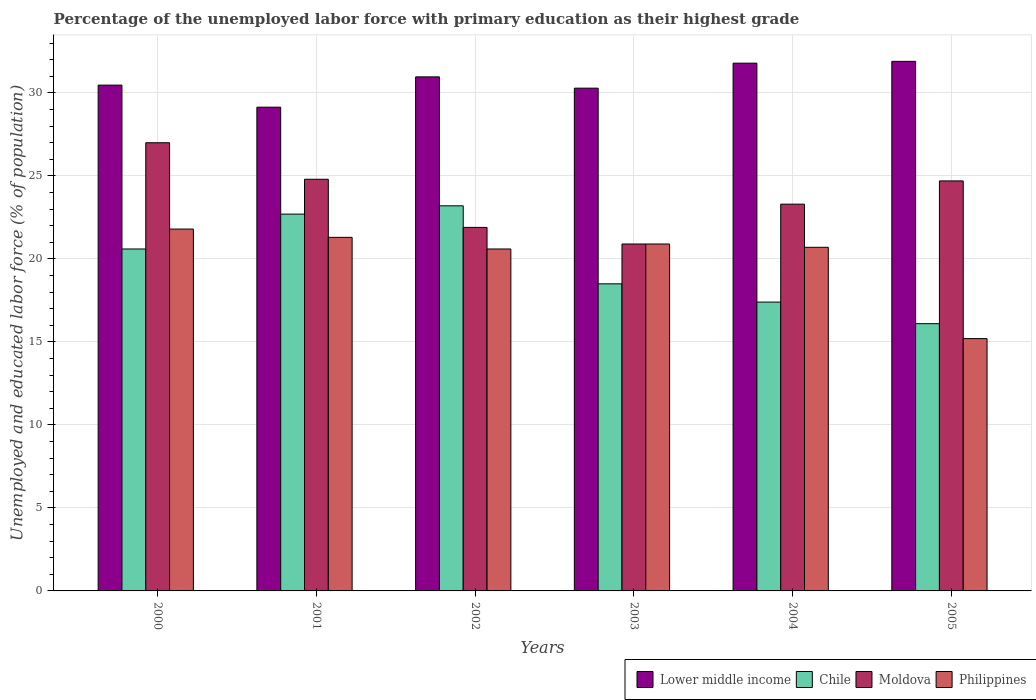How many different coloured bars are there?
Give a very brief answer. 4. How many groups of bars are there?
Your answer should be very brief. 6. Are the number of bars per tick equal to the number of legend labels?
Your answer should be compact. Yes. Are the number of bars on each tick of the X-axis equal?
Provide a short and direct response. Yes. How many bars are there on the 5th tick from the left?
Keep it short and to the point. 4. In how many cases, is the number of bars for a given year not equal to the number of legend labels?
Keep it short and to the point. 0. What is the percentage of the unemployed labor force with primary education in Philippines in 2005?
Provide a short and direct response. 15.2. Across all years, what is the maximum percentage of the unemployed labor force with primary education in Philippines?
Your answer should be very brief. 21.8. Across all years, what is the minimum percentage of the unemployed labor force with primary education in Chile?
Offer a terse response. 16.1. In which year was the percentage of the unemployed labor force with primary education in Philippines maximum?
Your answer should be compact. 2000. What is the total percentage of the unemployed labor force with primary education in Moldova in the graph?
Offer a very short reply. 142.6. What is the difference between the percentage of the unemployed labor force with primary education in Moldova in 2000 and that in 2004?
Ensure brevity in your answer.  3.7. What is the difference between the percentage of the unemployed labor force with primary education in Moldova in 2003 and the percentage of the unemployed labor force with primary education in Lower middle income in 2001?
Your answer should be very brief. -8.24. What is the average percentage of the unemployed labor force with primary education in Philippines per year?
Offer a very short reply. 20.08. In the year 2002, what is the difference between the percentage of the unemployed labor force with primary education in Chile and percentage of the unemployed labor force with primary education in Lower middle income?
Provide a succinct answer. -7.77. What is the ratio of the percentage of the unemployed labor force with primary education in Lower middle income in 2000 to that in 2004?
Ensure brevity in your answer.  0.96. Is the percentage of the unemployed labor force with primary education in Lower middle income in 2003 less than that in 2005?
Offer a terse response. Yes. Is the difference between the percentage of the unemployed labor force with primary education in Chile in 2000 and 2001 greater than the difference between the percentage of the unemployed labor force with primary education in Lower middle income in 2000 and 2001?
Your response must be concise. No. What is the difference between the highest and the second highest percentage of the unemployed labor force with primary education in Philippines?
Offer a terse response. 0.5. What is the difference between the highest and the lowest percentage of the unemployed labor force with primary education in Moldova?
Your answer should be compact. 6.1. In how many years, is the percentage of the unemployed labor force with primary education in Philippines greater than the average percentage of the unemployed labor force with primary education in Philippines taken over all years?
Make the answer very short. 5. What does the 4th bar from the left in 2000 represents?
Your answer should be very brief. Philippines. What does the 2nd bar from the right in 2005 represents?
Provide a short and direct response. Moldova. What is the difference between two consecutive major ticks on the Y-axis?
Offer a very short reply. 5. Are the values on the major ticks of Y-axis written in scientific E-notation?
Make the answer very short. No. Does the graph contain grids?
Your answer should be compact. Yes. What is the title of the graph?
Keep it short and to the point. Percentage of the unemployed labor force with primary education as their highest grade. Does "Suriname" appear as one of the legend labels in the graph?
Your answer should be very brief. No. What is the label or title of the X-axis?
Your answer should be compact. Years. What is the label or title of the Y-axis?
Offer a very short reply. Unemployed and educated labor force (% of population). What is the Unemployed and educated labor force (% of population) in Lower middle income in 2000?
Your answer should be compact. 30.47. What is the Unemployed and educated labor force (% of population) of Chile in 2000?
Your answer should be very brief. 20.6. What is the Unemployed and educated labor force (% of population) of Moldova in 2000?
Your answer should be compact. 27. What is the Unemployed and educated labor force (% of population) of Philippines in 2000?
Offer a very short reply. 21.8. What is the Unemployed and educated labor force (% of population) in Lower middle income in 2001?
Ensure brevity in your answer.  29.14. What is the Unemployed and educated labor force (% of population) in Chile in 2001?
Ensure brevity in your answer.  22.7. What is the Unemployed and educated labor force (% of population) in Moldova in 2001?
Provide a succinct answer. 24.8. What is the Unemployed and educated labor force (% of population) of Philippines in 2001?
Offer a terse response. 21.3. What is the Unemployed and educated labor force (% of population) of Lower middle income in 2002?
Make the answer very short. 30.97. What is the Unemployed and educated labor force (% of population) in Chile in 2002?
Your answer should be very brief. 23.2. What is the Unemployed and educated labor force (% of population) in Moldova in 2002?
Your answer should be compact. 21.9. What is the Unemployed and educated labor force (% of population) of Philippines in 2002?
Keep it short and to the point. 20.6. What is the Unemployed and educated labor force (% of population) of Lower middle income in 2003?
Your answer should be very brief. 30.29. What is the Unemployed and educated labor force (% of population) in Moldova in 2003?
Provide a short and direct response. 20.9. What is the Unemployed and educated labor force (% of population) of Philippines in 2003?
Your answer should be very brief. 20.9. What is the Unemployed and educated labor force (% of population) of Lower middle income in 2004?
Your response must be concise. 31.79. What is the Unemployed and educated labor force (% of population) of Chile in 2004?
Offer a terse response. 17.4. What is the Unemployed and educated labor force (% of population) of Moldova in 2004?
Your answer should be compact. 23.3. What is the Unemployed and educated labor force (% of population) in Philippines in 2004?
Offer a terse response. 20.7. What is the Unemployed and educated labor force (% of population) of Lower middle income in 2005?
Keep it short and to the point. 31.9. What is the Unemployed and educated labor force (% of population) of Chile in 2005?
Provide a short and direct response. 16.1. What is the Unemployed and educated labor force (% of population) in Moldova in 2005?
Ensure brevity in your answer.  24.7. What is the Unemployed and educated labor force (% of population) in Philippines in 2005?
Make the answer very short. 15.2. Across all years, what is the maximum Unemployed and educated labor force (% of population) in Lower middle income?
Your answer should be very brief. 31.9. Across all years, what is the maximum Unemployed and educated labor force (% of population) of Chile?
Keep it short and to the point. 23.2. Across all years, what is the maximum Unemployed and educated labor force (% of population) of Moldova?
Offer a very short reply. 27. Across all years, what is the maximum Unemployed and educated labor force (% of population) of Philippines?
Give a very brief answer. 21.8. Across all years, what is the minimum Unemployed and educated labor force (% of population) of Lower middle income?
Offer a very short reply. 29.14. Across all years, what is the minimum Unemployed and educated labor force (% of population) of Chile?
Provide a succinct answer. 16.1. Across all years, what is the minimum Unemployed and educated labor force (% of population) in Moldova?
Your answer should be very brief. 20.9. Across all years, what is the minimum Unemployed and educated labor force (% of population) of Philippines?
Provide a short and direct response. 15.2. What is the total Unemployed and educated labor force (% of population) in Lower middle income in the graph?
Keep it short and to the point. 184.57. What is the total Unemployed and educated labor force (% of population) in Chile in the graph?
Your answer should be very brief. 118.5. What is the total Unemployed and educated labor force (% of population) in Moldova in the graph?
Provide a succinct answer. 142.6. What is the total Unemployed and educated labor force (% of population) in Philippines in the graph?
Your answer should be very brief. 120.5. What is the difference between the Unemployed and educated labor force (% of population) of Lower middle income in 2000 and that in 2001?
Provide a succinct answer. 1.33. What is the difference between the Unemployed and educated labor force (% of population) of Philippines in 2000 and that in 2001?
Provide a succinct answer. 0.5. What is the difference between the Unemployed and educated labor force (% of population) of Lower middle income in 2000 and that in 2002?
Your answer should be compact. -0.5. What is the difference between the Unemployed and educated labor force (% of population) in Chile in 2000 and that in 2002?
Offer a terse response. -2.6. What is the difference between the Unemployed and educated labor force (% of population) in Moldova in 2000 and that in 2002?
Offer a very short reply. 5.1. What is the difference between the Unemployed and educated labor force (% of population) of Philippines in 2000 and that in 2002?
Provide a succinct answer. 1.2. What is the difference between the Unemployed and educated labor force (% of population) of Lower middle income in 2000 and that in 2003?
Your response must be concise. 0.18. What is the difference between the Unemployed and educated labor force (% of population) in Chile in 2000 and that in 2003?
Give a very brief answer. 2.1. What is the difference between the Unemployed and educated labor force (% of population) in Moldova in 2000 and that in 2003?
Ensure brevity in your answer.  6.1. What is the difference between the Unemployed and educated labor force (% of population) in Lower middle income in 2000 and that in 2004?
Offer a terse response. -1.32. What is the difference between the Unemployed and educated labor force (% of population) in Chile in 2000 and that in 2004?
Your answer should be very brief. 3.2. What is the difference between the Unemployed and educated labor force (% of population) of Moldova in 2000 and that in 2004?
Give a very brief answer. 3.7. What is the difference between the Unemployed and educated labor force (% of population) of Lower middle income in 2000 and that in 2005?
Keep it short and to the point. -1.43. What is the difference between the Unemployed and educated labor force (% of population) of Moldova in 2000 and that in 2005?
Offer a terse response. 2.3. What is the difference between the Unemployed and educated labor force (% of population) in Philippines in 2000 and that in 2005?
Your answer should be very brief. 6.6. What is the difference between the Unemployed and educated labor force (% of population) of Lower middle income in 2001 and that in 2002?
Your answer should be very brief. -1.83. What is the difference between the Unemployed and educated labor force (% of population) of Moldova in 2001 and that in 2002?
Give a very brief answer. 2.9. What is the difference between the Unemployed and educated labor force (% of population) in Lower middle income in 2001 and that in 2003?
Your response must be concise. -1.15. What is the difference between the Unemployed and educated labor force (% of population) in Moldova in 2001 and that in 2003?
Make the answer very short. 3.9. What is the difference between the Unemployed and educated labor force (% of population) of Lower middle income in 2001 and that in 2004?
Your answer should be compact. -2.65. What is the difference between the Unemployed and educated labor force (% of population) in Moldova in 2001 and that in 2004?
Offer a very short reply. 1.5. What is the difference between the Unemployed and educated labor force (% of population) of Lower middle income in 2001 and that in 2005?
Your answer should be very brief. -2.76. What is the difference between the Unemployed and educated labor force (% of population) of Chile in 2001 and that in 2005?
Offer a terse response. 6.6. What is the difference between the Unemployed and educated labor force (% of population) in Moldova in 2001 and that in 2005?
Provide a short and direct response. 0.1. What is the difference between the Unemployed and educated labor force (% of population) of Lower middle income in 2002 and that in 2003?
Keep it short and to the point. 0.68. What is the difference between the Unemployed and educated labor force (% of population) in Chile in 2002 and that in 2003?
Ensure brevity in your answer.  4.7. What is the difference between the Unemployed and educated labor force (% of population) in Moldova in 2002 and that in 2003?
Offer a very short reply. 1. What is the difference between the Unemployed and educated labor force (% of population) in Lower middle income in 2002 and that in 2004?
Provide a short and direct response. -0.83. What is the difference between the Unemployed and educated labor force (% of population) in Chile in 2002 and that in 2004?
Make the answer very short. 5.8. What is the difference between the Unemployed and educated labor force (% of population) of Philippines in 2002 and that in 2004?
Offer a terse response. -0.1. What is the difference between the Unemployed and educated labor force (% of population) of Lower middle income in 2002 and that in 2005?
Offer a very short reply. -0.93. What is the difference between the Unemployed and educated labor force (% of population) in Chile in 2002 and that in 2005?
Offer a very short reply. 7.1. What is the difference between the Unemployed and educated labor force (% of population) in Moldova in 2002 and that in 2005?
Your answer should be compact. -2.8. What is the difference between the Unemployed and educated labor force (% of population) of Philippines in 2002 and that in 2005?
Keep it short and to the point. 5.4. What is the difference between the Unemployed and educated labor force (% of population) of Lower middle income in 2003 and that in 2004?
Your answer should be very brief. -1.51. What is the difference between the Unemployed and educated labor force (% of population) of Chile in 2003 and that in 2004?
Provide a succinct answer. 1.1. What is the difference between the Unemployed and educated labor force (% of population) of Lower middle income in 2003 and that in 2005?
Provide a short and direct response. -1.62. What is the difference between the Unemployed and educated labor force (% of population) of Chile in 2003 and that in 2005?
Make the answer very short. 2.4. What is the difference between the Unemployed and educated labor force (% of population) in Lower middle income in 2004 and that in 2005?
Make the answer very short. -0.11. What is the difference between the Unemployed and educated labor force (% of population) in Philippines in 2004 and that in 2005?
Make the answer very short. 5.5. What is the difference between the Unemployed and educated labor force (% of population) in Lower middle income in 2000 and the Unemployed and educated labor force (% of population) in Chile in 2001?
Your answer should be compact. 7.77. What is the difference between the Unemployed and educated labor force (% of population) in Lower middle income in 2000 and the Unemployed and educated labor force (% of population) in Moldova in 2001?
Your answer should be compact. 5.67. What is the difference between the Unemployed and educated labor force (% of population) in Lower middle income in 2000 and the Unemployed and educated labor force (% of population) in Philippines in 2001?
Your response must be concise. 9.17. What is the difference between the Unemployed and educated labor force (% of population) of Chile in 2000 and the Unemployed and educated labor force (% of population) of Moldova in 2001?
Ensure brevity in your answer.  -4.2. What is the difference between the Unemployed and educated labor force (% of population) in Chile in 2000 and the Unemployed and educated labor force (% of population) in Philippines in 2001?
Your answer should be very brief. -0.7. What is the difference between the Unemployed and educated labor force (% of population) in Lower middle income in 2000 and the Unemployed and educated labor force (% of population) in Chile in 2002?
Your response must be concise. 7.27. What is the difference between the Unemployed and educated labor force (% of population) in Lower middle income in 2000 and the Unemployed and educated labor force (% of population) in Moldova in 2002?
Give a very brief answer. 8.57. What is the difference between the Unemployed and educated labor force (% of population) in Lower middle income in 2000 and the Unemployed and educated labor force (% of population) in Philippines in 2002?
Your answer should be very brief. 9.87. What is the difference between the Unemployed and educated labor force (% of population) in Chile in 2000 and the Unemployed and educated labor force (% of population) in Moldova in 2002?
Your answer should be compact. -1.3. What is the difference between the Unemployed and educated labor force (% of population) of Chile in 2000 and the Unemployed and educated labor force (% of population) of Philippines in 2002?
Your answer should be very brief. 0. What is the difference between the Unemployed and educated labor force (% of population) in Moldova in 2000 and the Unemployed and educated labor force (% of population) in Philippines in 2002?
Make the answer very short. 6.4. What is the difference between the Unemployed and educated labor force (% of population) in Lower middle income in 2000 and the Unemployed and educated labor force (% of population) in Chile in 2003?
Keep it short and to the point. 11.97. What is the difference between the Unemployed and educated labor force (% of population) of Lower middle income in 2000 and the Unemployed and educated labor force (% of population) of Moldova in 2003?
Provide a succinct answer. 9.57. What is the difference between the Unemployed and educated labor force (% of population) of Lower middle income in 2000 and the Unemployed and educated labor force (% of population) of Philippines in 2003?
Give a very brief answer. 9.57. What is the difference between the Unemployed and educated labor force (% of population) of Chile in 2000 and the Unemployed and educated labor force (% of population) of Philippines in 2003?
Keep it short and to the point. -0.3. What is the difference between the Unemployed and educated labor force (% of population) of Lower middle income in 2000 and the Unemployed and educated labor force (% of population) of Chile in 2004?
Your answer should be very brief. 13.07. What is the difference between the Unemployed and educated labor force (% of population) of Lower middle income in 2000 and the Unemployed and educated labor force (% of population) of Moldova in 2004?
Your answer should be compact. 7.17. What is the difference between the Unemployed and educated labor force (% of population) of Lower middle income in 2000 and the Unemployed and educated labor force (% of population) of Philippines in 2004?
Offer a terse response. 9.77. What is the difference between the Unemployed and educated labor force (% of population) in Chile in 2000 and the Unemployed and educated labor force (% of population) in Moldova in 2004?
Keep it short and to the point. -2.7. What is the difference between the Unemployed and educated labor force (% of population) in Moldova in 2000 and the Unemployed and educated labor force (% of population) in Philippines in 2004?
Offer a terse response. 6.3. What is the difference between the Unemployed and educated labor force (% of population) in Lower middle income in 2000 and the Unemployed and educated labor force (% of population) in Chile in 2005?
Keep it short and to the point. 14.37. What is the difference between the Unemployed and educated labor force (% of population) of Lower middle income in 2000 and the Unemployed and educated labor force (% of population) of Moldova in 2005?
Keep it short and to the point. 5.77. What is the difference between the Unemployed and educated labor force (% of population) of Lower middle income in 2000 and the Unemployed and educated labor force (% of population) of Philippines in 2005?
Keep it short and to the point. 15.27. What is the difference between the Unemployed and educated labor force (% of population) of Chile in 2000 and the Unemployed and educated labor force (% of population) of Moldova in 2005?
Your answer should be compact. -4.1. What is the difference between the Unemployed and educated labor force (% of population) in Chile in 2000 and the Unemployed and educated labor force (% of population) in Philippines in 2005?
Make the answer very short. 5.4. What is the difference between the Unemployed and educated labor force (% of population) of Lower middle income in 2001 and the Unemployed and educated labor force (% of population) of Chile in 2002?
Your answer should be very brief. 5.94. What is the difference between the Unemployed and educated labor force (% of population) in Lower middle income in 2001 and the Unemployed and educated labor force (% of population) in Moldova in 2002?
Make the answer very short. 7.24. What is the difference between the Unemployed and educated labor force (% of population) of Lower middle income in 2001 and the Unemployed and educated labor force (% of population) of Philippines in 2002?
Your answer should be compact. 8.54. What is the difference between the Unemployed and educated labor force (% of population) in Chile in 2001 and the Unemployed and educated labor force (% of population) in Moldova in 2002?
Give a very brief answer. 0.8. What is the difference between the Unemployed and educated labor force (% of population) in Chile in 2001 and the Unemployed and educated labor force (% of population) in Philippines in 2002?
Offer a very short reply. 2.1. What is the difference between the Unemployed and educated labor force (% of population) in Moldova in 2001 and the Unemployed and educated labor force (% of population) in Philippines in 2002?
Keep it short and to the point. 4.2. What is the difference between the Unemployed and educated labor force (% of population) in Lower middle income in 2001 and the Unemployed and educated labor force (% of population) in Chile in 2003?
Your answer should be very brief. 10.64. What is the difference between the Unemployed and educated labor force (% of population) of Lower middle income in 2001 and the Unemployed and educated labor force (% of population) of Moldova in 2003?
Give a very brief answer. 8.24. What is the difference between the Unemployed and educated labor force (% of population) in Lower middle income in 2001 and the Unemployed and educated labor force (% of population) in Philippines in 2003?
Keep it short and to the point. 8.24. What is the difference between the Unemployed and educated labor force (% of population) in Chile in 2001 and the Unemployed and educated labor force (% of population) in Philippines in 2003?
Make the answer very short. 1.8. What is the difference between the Unemployed and educated labor force (% of population) in Moldova in 2001 and the Unemployed and educated labor force (% of population) in Philippines in 2003?
Your response must be concise. 3.9. What is the difference between the Unemployed and educated labor force (% of population) of Lower middle income in 2001 and the Unemployed and educated labor force (% of population) of Chile in 2004?
Provide a short and direct response. 11.74. What is the difference between the Unemployed and educated labor force (% of population) of Lower middle income in 2001 and the Unemployed and educated labor force (% of population) of Moldova in 2004?
Make the answer very short. 5.84. What is the difference between the Unemployed and educated labor force (% of population) in Lower middle income in 2001 and the Unemployed and educated labor force (% of population) in Philippines in 2004?
Offer a very short reply. 8.44. What is the difference between the Unemployed and educated labor force (% of population) of Chile in 2001 and the Unemployed and educated labor force (% of population) of Moldova in 2004?
Your response must be concise. -0.6. What is the difference between the Unemployed and educated labor force (% of population) in Lower middle income in 2001 and the Unemployed and educated labor force (% of population) in Chile in 2005?
Keep it short and to the point. 13.04. What is the difference between the Unemployed and educated labor force (% of population) in Lower middle income in 2001 and the Unemployed and educated labor force (% of population) in Moldova in 2005?
Offer a very short reply. 4.44. What is the difference between the Unemployed and educated labor force (% of population) in Lower middle income in 2001 and the Unemployed and educated labor force (% of population) in Philippines in 2005?
Give a very brief answer. 13.94. What is the difference between the Unemployed and educated labor force (% of population) in Chile in 2001 and the Unemployed and educated labor force (% of population) in Moldova in 2005?
Provide a short and direct response. -2. What is the difference between the Unemployed and educated labor force (% of population) in Moldova in 2001 and the Unemployed and educated labor force (% of population) in Philippines in 2005?
Your answer should be very brief. 9.6. What is the difference between the Unemployed and educated labor force (% of population) of Lower middle income in 2002 and the Unemployed and educated labor force (% of population) of Chile in 2003?
Ensure brevity in your answer.  12.47. What is the difference between the Unemployed and educated labor force (% of population) of Lower middle income in 2002 and the Unemployed and educated labor force (% of population) of Moldova in 2003?
Your answer should be very brief. 10.07. What is the difference between the Unemployed and educated labor force (% of population) of Lower middle income in 2002 and the Unemployed and educated labor force (% of population) of Philippines in 2003?
Your response must be concise. 10.07. What is the difference between the Unemployed and educated labor force (% of population) in Chile in 2002 and the Unemployed and educated labor force (% of population) in Philippines in 2003?
Offer a very short reply. 2.3. What is the difference between the Unemployed and educated labor force (% of population) of Moldova in 2002 and the Unemployed and educated labor force (% of population) of Philippines in 2003?
Your answer should be very brief. 1. What is the difference between the Unemployed and educated labor force (% of population) of Lower middle income in 2002 and the Unemployed and educated labor force (% of population) of Chile in 2004?
Offer a very short reply. 13.57. What is the difference between the Unemployed and educated labor force (% of population) in Lower middle income in 2002 and the Unemployed and educated labor force (% of population) in Moldova in 2004?
Your response must be concise. 7.67. What is the difference between the Unemployed and educated labor force (% of population) in Lower middle income in 2002 and the Unemployed and educated labor force (% of population) in Philippines in 2004?
Ensure brevity in your answer.  10.27. What is the difference between the Unemployed and educated labor force (% of population) in Moldova in 2002 and the Unemployed and educated labor force (% of population) in Philippines in 2004?
Keep it short and to the point. 1.2. What is the difference between the Unemployed and educated labor force (% of population) in Lower middle income in 2002 and the Unemployed and educated labor force (% of population) in Chile in 2005?
Your response must be concise. 14.87. What is the difference between the Unemployed and educated labor force (% of population) of Lower middle income in 2002 and the Unemployed and educated labor force (% of population) of Moldova in 2005?
Provide a succinct answer. 6.27. What is the difference between the Unemployed and educated labor force (% of population) of Lower middle income in 2002 and the Unemployed and educated labor force (% of population) of Philippines in 2005?
Your answer should be compact. 15.77. What is the difference between the Unemployed and educated labor force (% of population) in Moldova in 2002 and the Unemployed and educated labor force (% of population) in Philippines in 2005?
Ensure brevity in your answer.  6.7. What is the difference between the Unemployed and educated labor force (% of population) of Lower middle income in 2003 and the Unemployed and educated labor force (% of population) of Chile in 2004?
Give a very brief answer. 12.89. What is the difference between the Unemployed and educated labor force (% of population) in Lower middle income in 2003 and the Unemployed and educated labor force (% of population) in Moldova in 2004?
Offer a terse response. 6.99. What is the difference between the Unemployed and educated labor force (% of population) of Lower middle income in 2003 and the Unemployed and educated labor force (% of population) of Philippines in 2004?
Provide a short and direct response. 9.59. What is the difference between the Unemployed and educated labor force (% of population) of Chile in 2003 and the Unemployed and educated labor force (% of population) of Moldova in 2004?
Give a very brief answer. -4.8. What is the difference between the Unemployed and educated labor force (% of population) of Moldova in 2003 and the Unemployed and educated labor force (% of population) of Philippines in 2004?
Provide a short and direct response. 0.2. What is the difference between the Unemployed and educated labor force (% of population) in Lower middle income in 2003 and the Unemployed and educated labor force (% of population) in Chile in 2005?
Provide a succinct answer. 14.19. What is the difference between the Unemployed and educated labor force (% of population) of Lower middle income in 2003 and the Unemployed and educated labor force (% of population) of Moldova in 2005?
Provide a succinct answer. 5.59. What is the difference between the Unemployed and educated labor force (% of population) in Lower middle income in 2003 and the Unemployed and educated labor force (% of population) in Philippines in 2005?
Give a very brief answer. 15.09. What is the difference between the Unemployed and educated labor force (% of population) of Chile in 2003 and the Unemployed and educated labor force (% of population) of Philippines in 2005?
Ensure brevity in your answer.  3.3. What is the difference between the Unemployed and educated labor force (% of population) in Lower middle income in 2004 and the Unemployed and educated labor force (% of population) in Chile in 2005?
Offer a terse response. 15.69. What is the difference between the Unemployed and educated labor force (% of population) of Lower middle income in 2004 and the Unemployed and educated labor force (% of population) of Moldova in 2005?
Keep it short and to the point. 7.09. What is the difference between the Unemployed and educated labor force (% of population) of Lower middle income in 2004 and the Unemployed and educated labor force (% of population) of Philippines in 2005?
Provide a short and direct response. 16.59. What is the difference between the Unemployed and educated labor force (% of population) in Chile in 2004 and the Unemployed and educated labor force (% of population) in Moldova in 2005?
Provide a succinct answer. -7.3. What is the difference between the Unemployed and educated labor force (% of population) of Chile in 2004 and the Unemployed and educated labor force (% of population) of Philippines in 2005?
Provide a succinct answer. 2.2. What is the difference between the Unemployed and educated labor force (% of population) of Moldova in 2004 and the Unemployed and educated labor force (% of population) of Philippines in 2005?
Offer a terse response. 8.1. What is the average Unemployed and educated labor force (% of population) of Lower middle income per year?
Your response must be concise. 30.76. What is the average Unemployed and educated labor force (% of population) in Chile per year?
Your response must be concise. 19.75. What is the average Unemployed and educated labor force (% of population) of Moldova per year?
Offer a very short reply. 23.77. What is the average Unemployed and educated labor force (% of population) of Philippines per year?
Give a very brief answer. 20.08. In the year 2000, what is the difference between the Unemployed and educated labor force (% of population) of Lower middle income and Unemployed and educated labor force (% of population) of Chile?
Give a very brief answer. 9.87. In the year 2000, what is the difference between the Unemployed and educated labor force (% of population) in Lower middle income and Unemployed and educated labor force (% of population) in Moldova?
Your answer should be very brief. 3.47. In the year 2000, what is the difference between the Unemployed and educated labor force (% of population) of Lower middle income and Unemployed and educated labor force (% of population) of Philippines?
Give a very brief answer. 8.67. In the year 2000, what is the difference between the Unemployed and educated labor force (% of population) of Chile and Unemployed and educated labor force (% of population) of Philippines?
Your answer should be very brief. -1.2. In the year 2000, what is the difference between the Unemployed and educated labor force (% of population) in Moldova and Unemployed and educated labor force (% of population) in Philippines?
Keep it short and to the point. 5.2. In the year 2001, what is the difference between the Unemployed and educated labor force (% of population) of Lower middle income and Unemployed and educated labor force (% of population) of Chile?
Give a very brief answer. 6.44. In the year 2001, what is the difference between the Unemployed and educated labor force (% of population) of Lower middle income and Unemployed and educated labor force (% of population) of Moldova?
Make the answer very short. 4.34. In the year 2001, what is the difference between the Unemployed and educated labor force (% of population) of Lower middle income and Unemployed and educated labor force (% of population) of Philippines?
Your answer should be very brief. 7.84. In the year 2001, what is the difference between the Unemployed and educated labor force (% of population) in Chile and Unemployed and educated labor force (% of population) in Moldova?
Provide a short and direct response. -2.1. In the year 2001, what is the difference between the Unemployed and educated labor force (% of population) of Chile and Unemployed and educated labor force (% of population) of Philippines?
Provide a short and direct response. 1.4. In the year 2001, what is the difference between the Unemployed and educated labor force (% of population) of Moldova and Unemployed and educated labor force (% of population) of Philippines?
Offer a terse response. 3.5. In the year 2002, what is the difference between the Unemployed and educated labor force (% of population) of Lower middle income and Unemployed and educated labor force (% of population) of Chile?
Ensure brevity in your answer.  7.77. In the year 2002, what is the difference between the Unemployed and educated labor force (% of population) of Lower middle income and Unemployed and educated labor force (% of population) of Moldova?
Give a very brief answer. 9.07. In the year 2002, what is the difference between the Unemployed and educated labor force (% of population) of Lower middle income and Unemployed and educated labor force (% of population) of Philippines?
Offer a very short reply. 10.37. In the year 2002, what is the difference between the Unemployed and educated labor force (% of population) of Chile and Unemployed and educated labor force (% of population) of Moldova?
Provide a succinct answer. 1.3. In the year 2002, what is the difference between the Unemployed and educated labor force (% of population) of Chile and Unemployed and educated labor force (% of population) of Philippines?
Provide a succinct answer. 2.6. In the year 2003, what is the difference between the Unemployed and educated labor force (% of population) in Lower middle income and Unemployed and educated labor force (% of population) in Chile?
Provide a short and direct response. 11.79. In the year 2003, what is the difference between the Unemployed and educated labor force (% of population) in Lower middle income and Unemployed and educated labor force (% of population) in Moldova?
Ensure brevity in your answer.  9.39. In the year 2003, what is the difference between the Unemployed and educated labor force (% of population) of Lower middle income and Unemployed and educated labor force (% of population) of Philippines?
Offer a terse response. 9.39. In the year 2003, what is the difference between the Unemployed and educated labor force (% of population) in Chile and Unemployed and educated labor force (% of population) in Moldova?
Keep it short and to the point. -2.4. In the year 2003, what is the difference between the Unemployed and educated labor force (% of population) of Chile and Unemployed and educated labor force (% of population) of Philippines?
Offer a very short reply. -2.4. In the year 2004, what is the difference between the Unemployed and educated labor force (% of population) of Lower middle income and Unemployed and educated labor force (% of population) of Chile?
Keep it short and to the point. 14.39. In the year 2004, what is the difference between the Unemployed and educated labor force (% of population) in Lower middle income and Unemployed and educated labor force (% of population) in Moldova?
Offer a very short reply. 8.49. In the year 2004, what is the difference between the Unemployed and educated labor force (% of population) of Lower middle income and Unemployed and educated labor force (% of population) of Philippines?
Offer a terse response. 11.09. In the year 2004, what is the difference between the Unemployed and educated labor force (% of population) of Chile and Unemployed and educated labor force (% of population) of Philippines?
Your response must be concise. -3.3. In the year 2005, what is the difference between the Unemployed and educated labor force (% of population) in Lower middle income and Unemployed and educated labor force (% of population) in Chile?
Your response must be concise. 15.8. In the year 2005, what is the difference between the Unemployed and educated labor force (% of population) of Lower middle income and Unemployed and educated labor force (% of population) of Moldova?
Your answer should be very brief. 7.2. In the year 2005, what is the difference between the Unemployed and educated labor force (% of population) of Lower middle income and Unemployed and educated labor force (% of population) of Philippines?
Offer a terse response. 16.7. In the year 2005, what is the difference between the Unemployed and educated labor force (% of population) of Chile and Unemployed and educated labor force (% of population) of Moldova?
Ensure brevity in your answer.  -8.6. What is the ratio of the Unemployed and educated labor force (% of population) of Lower middle income in 2000 to that in 2001?
Give a very brief answer. 1.05. What is the ratio of the Unemployed and educated labor force (% of population) of Chile in 2000 to that in 2001?
Provide a short and direct response. 0.91. What is the ratio of the Unemployed and educated labor force (% of population) in Moldova in 2000 to that in 2001?
Your answer should be very brief. 1.09. What is the ratio of the Unemployed and educated labor force (% of population) of Philippines in 2000 to that in 2001?
Make the answer very short. 1.02. What is the ratio of the Unemployed and educated labor force (% of population) of Lower middle income in 2000 to that in 2002?
Ensure brevity in your answer.  0.98. What is the ratio of the Unemployed and educated labor force (% of population) of Chile in 2000 to that in 2002?
Offer a very short reply. 0.89. What is the ratio of the Unemployed and educated labor force (% of population) in Moldova in 2000 to that in 2002?
Your answer should be compact. 1.23. What is the ratio of the Unemployed and educated labor force (% of population) in Philippines in 2000 to that in 2002?
Ensure brevity in your answer.  1.06. What is the ratio of the Unemployed and educated labor force (% of population) of Chile in 2000 to that in 2003?
Offer a very short reply. 1.11. What is the ratio of the Unemployed and educated labor force (% of population) in Moldova in 2000 to that in 2003?
Offer a very short reply. 1.29. What is the ratio of the Unemployed and educated labor force (% of population) in Philippines in 2000 to that in 2003?
Ensure brevity in your answer.  1.04. What is the ratio of the Unemployed and educated labor force (% of population) of Lower middle income in 2000 to that in 2004?
Your answer should be compact. 0.96. What is the ratio of the Unemployed and educated labor force (% of population) of Chile in 2000 to that in 2004?
Offer a terse response. 1.18. What is the ratio of the Unemployed and educated labor force (% of population) in Moldova in 2000 to that in 2004?
Keep it short and to the point. 1.16. What is the ratio of the Unemployed and educated labor force (% of population) in Philippines in 2000 to that in 2004?
Your answer should be compact. 1.05. What is the ratio of the Unemployed and educated labor force (% of population) in Lower middle income in 2000 to that in 2005?
Give a very brief answer. 0.96. What is the ratio of the Unemployed and educated labor force (% of population) of Chile in 2000 to that in 2005?
Offer a very short reply. 1.28. What is the ratio of the Unemployed and educated labor force (% of population) in Moldova in 2000 to that in 2005?
Make the answer very short. 1.09. What is the ratio of the Unemployed and educated labor force (% of population) in Philippines in 2000 to that in 2005?
Your answer should be very brief. 1.43. What is the ratio of the Unemployed and educated labor force (% of population) in Lower middle income in 2001 to that in 2002?
Your answer should be very brief. 0.94. What is the ratio of the Unemployed and educated labor force (% of population) in Chile in 2001 to that in 2002?
Give a very brief answer. 0.98. What is the ratio of the Unemployed and educated labor force (% of population) in Moldova in 2001 to that in 2002?
Your answer should be compact. 1.13. What is the ratio of the Unemployed and educated labor force (% of population) in Philippines in 2001 to that in 2002?
Your response must be concise. 1.03. What is the ratio of the Unemployed and educated labor force (% of population) in Lower middle income in 2001 to that in 2003?
Provide a succinct answer. 0.96. What is the ratio of the Unemployed and educated labor force (% of population) of Chile in 2001 to that in 2003?
Your answer should be very brief. 1.23. What is the ratio of the Unemployed and educated labor force (% of population) of Moldova in 2001 to that in 2003?
Your answer should be very brief. 1.19. What is the ratio of the Unemployed and educated labor force (% of population) of Philippines in 2001 to that in 2003?
Ensure brevity in your answer.  1.02. What is the ratio of the Unemployed and educated labor force (% of population) of Lower middle income in 2001 to that in 2004?
Your answer should be very brief. 0.92. What is the ratio of the Unemployed and educated labor force (% of population) of Chile in 2001 to that in 2004?
Offer a very short reply. 1.3. What is the ratio of the Unemployed and educated labor force (% of population) of Moldova in 2001 to that in 2004?
Ensure brevity in your answer.  1.06. What is the ratio of the Unemployed and educated labor force (% of population) in Lower middle income in 2001 to that in 2005?
Provide a succinct answer. 0.91. What is the ratio of the Unemployed and educated labor force (% of population) in Chile in 2001 to that in 2005?
Offer a very short reply. 1.41. What is the ratio of the Unemployed and educated labor force (% of population) of Philippines in 2001 to that in 2005?
Your response must be concise. 1.4. What is the ratio of the Unemployed and educated labor force (% of population) of Lower middle income in 2002 to that in 2003?
Your answer should be compact. 1.02. What is the ratio of the Unemployed and educated labor force (% of population) of Chile in 2002 to that in 2003?
Your response must be concise. 1.25. What is the ratio of the Unemployed and educated labor force (% of population) of Moldova in 2002 to that in 2003?
Your answer should be very brief. 1.05. What is the ratio of the Unemployed and educated labor force (% of population) of Philippines in 2002 to that in 2003?
Your answer should be very brief. 0.99. What is the ratio of the Unemployed and educated labor force (% of population) of Chile in 2002 to that in 2004?
Provide a short and direct response. 1.33. What is the ratio of the Unemployed and educated labor force (% of population) of Moldova in 2002 to that in 2004?
Offer a very short reply. 0.94. What is the ratio of the Unemployed and educated labor force (% of population) in Lower middle income in 2002 to that in 2005?
Offer a terse response. 0.97. What is the ratio of the Unemployed and educated labor force (% of population) of Chile in 2002 to that in 2005?
Your answer should be very brief. 1.44. What is the ratio of the Unemployed and educated labor force (% of population) in Moldova in 2002 to that in 2005?
Provide a short and direct response. 0.89. What is the ratio of the Unemployed and educated labor force (% of population) of Philippines in 2002 to that in 2005?
Provide a succinct answer. 1.36. What is the ratio of the Unemployed and educated labor force (% of population) of Lower middle income in 2003 to that in 2004?
Provide a short and direct response. 0.95. What is the ratio of the Unemployed and educated labor force (% of population) in Chile in 2003 to that in 2004?
Your answer should be compact. 1.06. What is the ratio of the Unemployed and educated labor force (% of population) in Moldova in 2003 to that in 2004?
Your answer should be compact. 0.9. What is the ratio of the Unemployed and educated labor force (% of population) of Philippines in 2003 to that in 2004?
Your answer should be very brief. 1.01. What is the ratio of the Unemployed and educated labor force (% of population) in Lower middle income in 2003 to that in 2005?
Keep it short and to the point. 0.95. What is the ratio of the Unemployed and educated labor force (% of population) in Chile in 2003 to that in 2005?
Provide a succinct answer. 1.15. What is the ratio of the Unemployed and educated labor force (% of population) of Moldova in 2003 to that in 2005?
Ensure brevity in your answer.  0.85. What is the ratio of the Unemployed and educated labor force (% of population) in Philippines in 2003 to that in 2005?
Your response must be concise. 1.38. What is the ratio of the Unemployed and educated labor force (% of population) in Chile in 2004 to that in 2005?
Keep it short and to the point. 1.08. What is the ratio of the Unemployed and educated labor force (% of population) of Moldova in 2004 to that in 2005?
Keep it short and to the point. 0.94. What is the ratio of the Unemployed and educated labor force (% of population) of Philippines in 2004 to that in 2005?
Make the answer very short. 1.36. What is the difference between the highest and the second highest Unemployed and educated labor force (% of population) of Lower middle income?
Provide a short and direct response. 0.11. What is the difference between the highest and the second highest Unemployed and educated labor force (% of population) in Chile?
Your answer should be very brief. 0.5. What is the difference between the highest and the second highest Unemployed and educated labor force (% of population) in Moldova?
Your answer should be very brief. 2.2. What is the difference between the highest and the second highest Unemployed and educated labor force (% of population) of Philippines?
Give a very brief answer. 0.5. What is the difference between the highest and the lowest Unemployed and educated labor force (% of population) of Lower middle income?
Your answer should be very brief. 2.76. What is the difference between the highest and the lowest Unemployed and educated labor force (% of population) of Moldova?
Offer a very short reply. 6.1. 